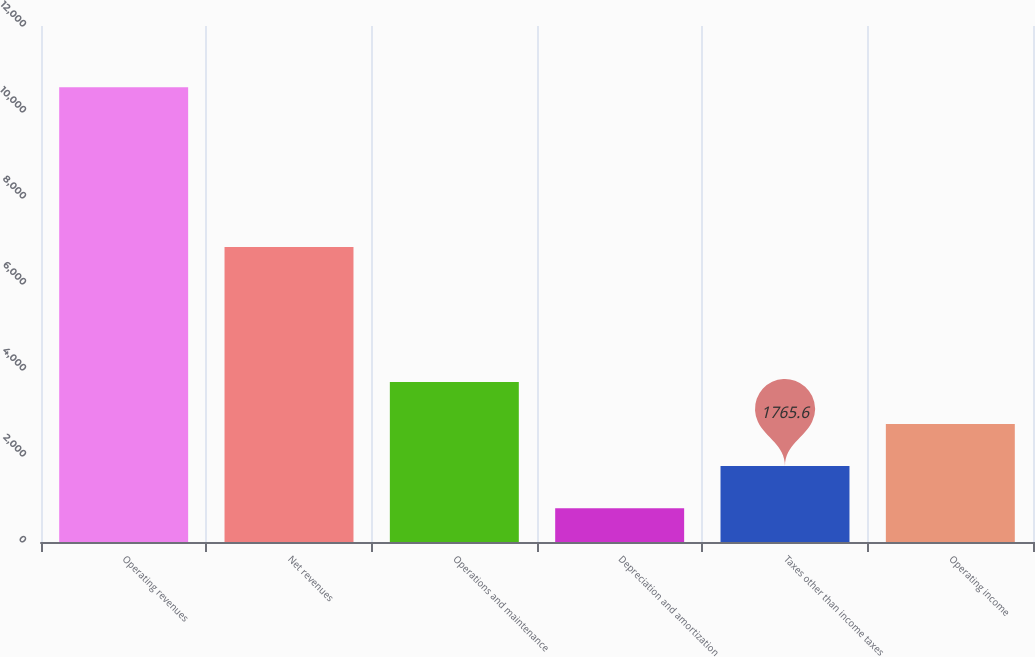Convert chart to OTSL. <chart><loc_0><loc_0><loc_500><loc_500><bar_chart><fcel>Operating revenues<fcel>Net revenues<fcel>Operations and maintenance<fcel>Depreciation and amortization<fcel>Taxes other than income taxes<fcel>Operating income<nl><fcel>10573<fcel>6858<fcel>3722.8<fcel>787<fcel>1765.6<fcel>2744.2<nl></chart> 